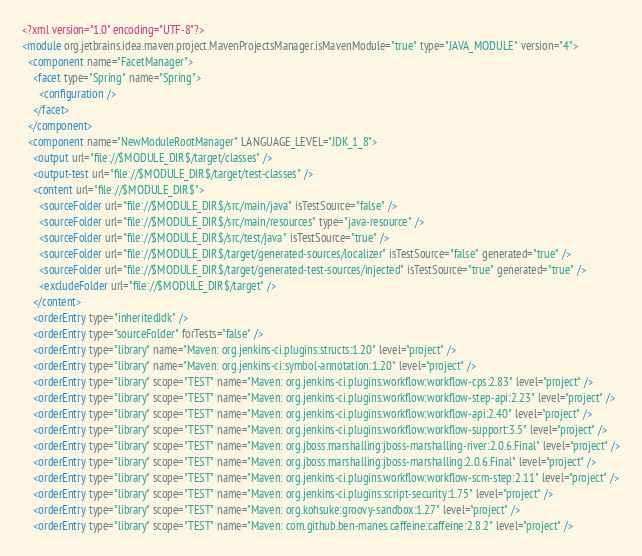Convert code to text. <code><loc_0><loc_0><loc_500><loc_500><_XML_><?xml version="1.0" encoding="UTF-8"?>
<module org.jetbrains.idea.maven.project.MavenProjectsManager.isMavenModule="true" type="JAVA_MODULE" version="4">
  <component name="FacetManager">
    <facet type="Spring" name="Spring">
      <configuration />
    </facet>
  </component>
  <component name="NewModuleRootManager" LANGUAGE_LEVEL="JDK_1_8">
    <output url="file://$MODULE_DIR$/target/classes" />
    <output-test url="file://$MODULE_DIR$/target/test-classes" />
    <content url="file://$MODULE_DIR$">
      <sourceFolder url="file://$MODULE_DIR$/src/main/java" isTestSource="false" />
      <sourceFolder url="file://$MODULE_DIR$/src/main/resources" type="java-resource" />
      <sourceFolder url="file://$MODULE_DIR$/src/test/java" isTestSource="true" />
      <sourceFolder url="file://$MODULE_DIR$/target/generated-sources/localizer" isTestSource="false" generated="true" />
      <sourceFolder url="file://$MODULE_DIR$/target/generated-test-sources/injected" isTestSource="true" generated="true" />
      <excludeFolder url="file://$MODULE_DIR$/target" />
    </content>
    <orderEntry type="inheritedJdk" />
    <orderEntry type="sourceFolder" forTests="false" />
    <orderEntry type="library" name="Maven: org.jenkins-ci.plugins:structs:1.20" level="project" />
    <orderEntry type="library" name="Maven: org.jenkins-ci:symbol-annotation:1.20" level="project" />
    <orderEntry type="library" scope="TEST" name="Maven: org.jenkins-ci.plugins.workflow:workflow-cps:2.83" level="project" />
    <orderEntry type="library" scope="TEST" name="Maven: org.jenkins-ci.plugins.workflow:workflow-step-api:2.23" level="project" />
    <orderEntry type="library" scope="TEST" name="Maven: org.jenkins-ci.plugins.workflow:workflow-api:2.40" level="project" />
    <orderEntry type="library" scope="TEST" name="Maven: org.jenkins-ci.plugins.workflow:workflow-support:3.5" level="project" />
    <orderEntry type="library" scope="TEST" name="Maven: org.jboss.marshalling:jboss-marshalling-river:2.0.6.Final" level="project" />
    <orderEntry type="library" scope="TEST" name="Maven: org.jboss.marshalling:jboss-marshalling:2.0.6.Final" level="project" />
    <orderEntry type="library" scope="TEST" name="Maven: org.jenkins-ci.plugins.workflow:workflow-scm-step:2.11" level="project" />
    <orderEntry type="library" scope="TEST" name="Maven: org.jenkins-ci.plugins:script-security:1.75" level="project" />
    <orderEntry type="library" scope="TEST" name="Maven: org.kohsuke:groovy-sandbox:1.27" level="project" />
    <orderEntry type="library" scope="TEST" name="Maven: com.github.ben-manes.caffeine:caffeine:2.8.2" level="project" /></code> 